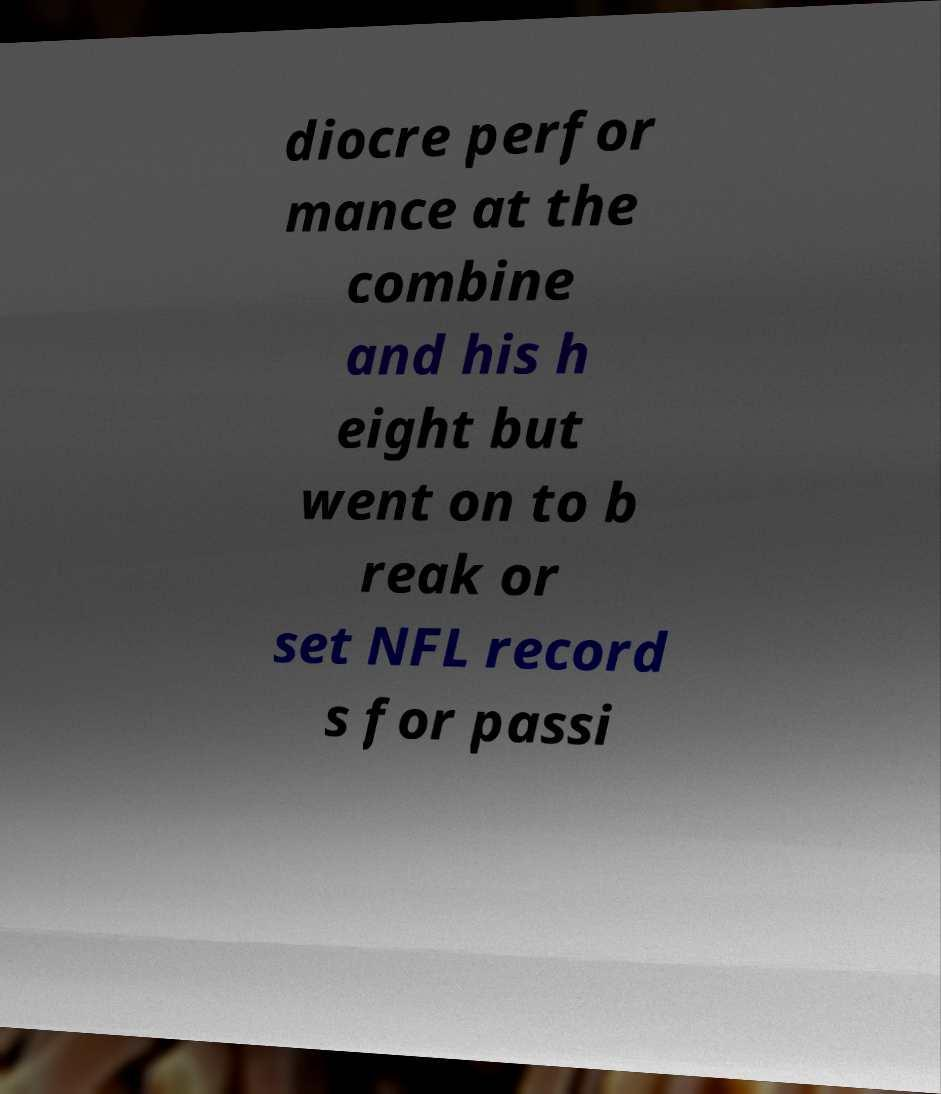Please identify and transcribe the text found in this image. diocre perfor mance at the combine and his h eight but went on to b reak or set NFL record s for passi 